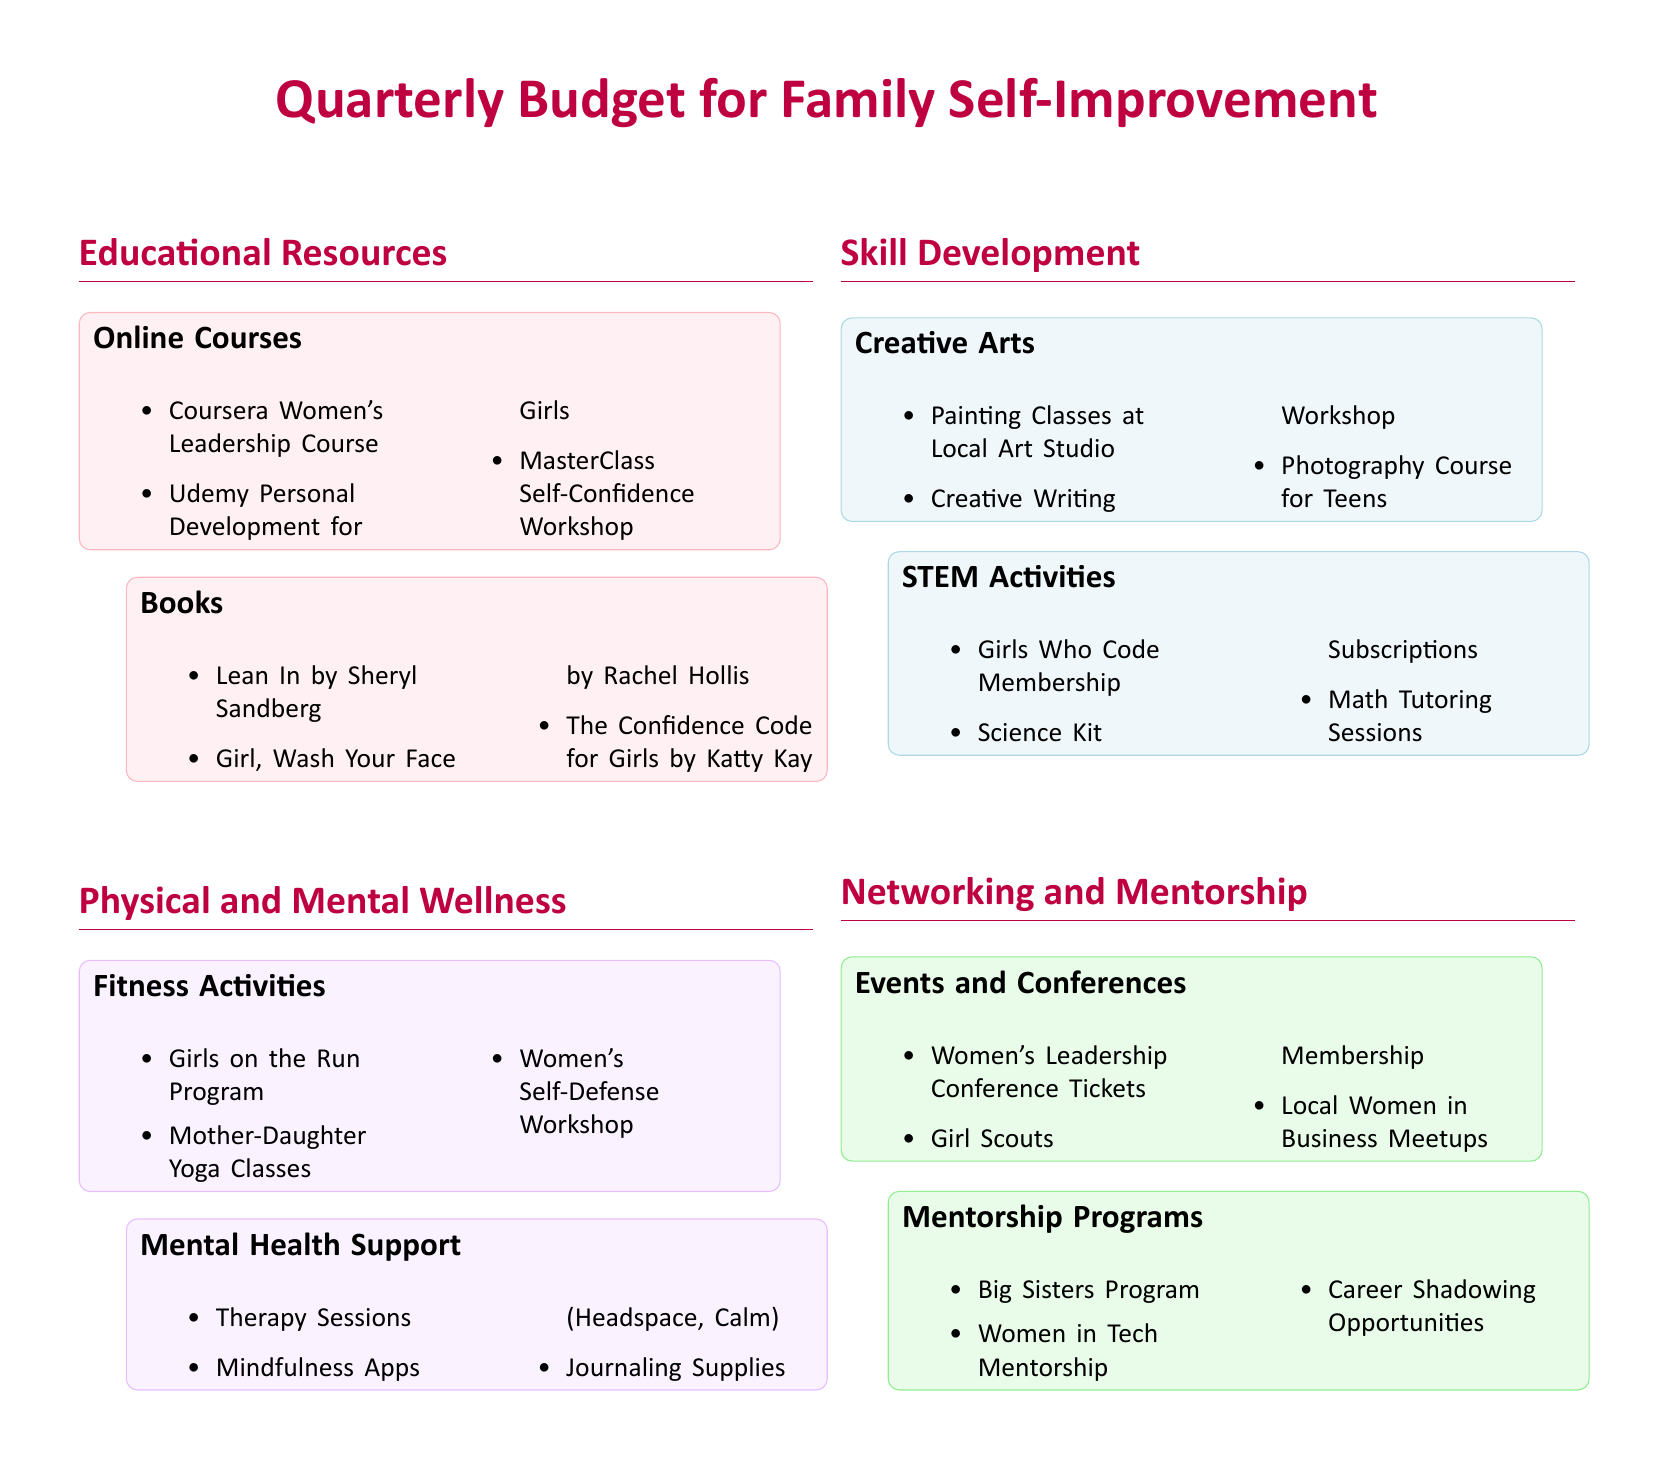What are the three online courses listed under Educational Resources? The online courses listed are Coursera Women's Leadership Course, Udemy Personal Development for Girls, and MasterClass Self-Confidence Workshop.
Answer: Coursera Women's Leadership Course, Udemy Personal Development for Girls, MasterClass Self-Confidence Workshop What book focuses on self-confidence for girls? The book that focuses on self-confidence for girls is The Confidence Code for Girls by Katty Kay.
Answer: The Confidence Code for Girls What fitness activity encourages running? The fitness activity that encourages running is Girls on the Run Program.
Answer: Girls on the Run Program Name a mental health support resource mentioned. The document lists Therapy Sessions, Mindfulness Apps, and Journaling Supplies as mental health support resources.
Answer: Therapy Sessions How many creative arts activities are listed? There are three creative arts activities mentioned: Painting Classes, Creative Writing Workshop, and Photography Course.
Answer: Three What is the membership program for coding mentioned in STEM Activities? The membership program for coding is Girls Who Code Membership.
Answer: Girls Who Code Membership List an event for networking and mentorship. The event listed for networking and mentorship is Women's Leadership Conference Tickets.
Answer: Women's Leadership Conference Tickets What program pairs girls with mentors? The program that pairs girls with mentors is the Big Sisters Program.
Answer: Big Sisters Program Which online course is designed specifically for girls? The online course designed specifically for girls is Udemy Personal Development for Girls.
Answer: Udemy Personal Development for Girls 